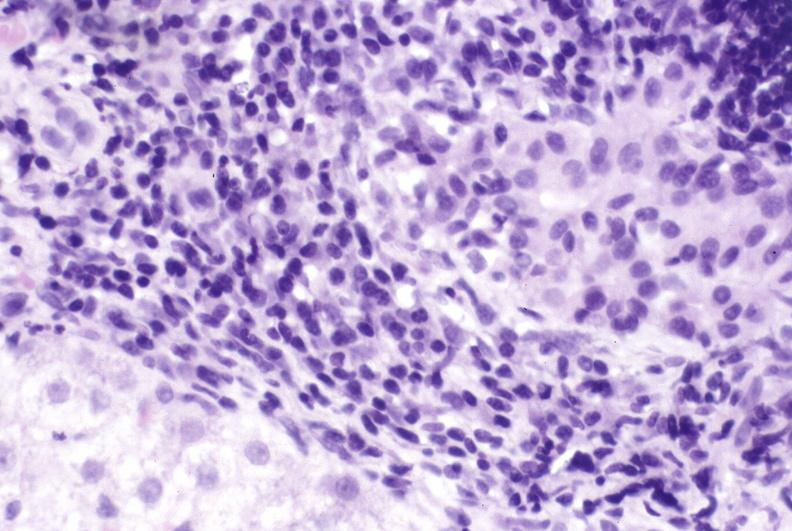what is present?
Answer the question using a single word or phrase. Liver 